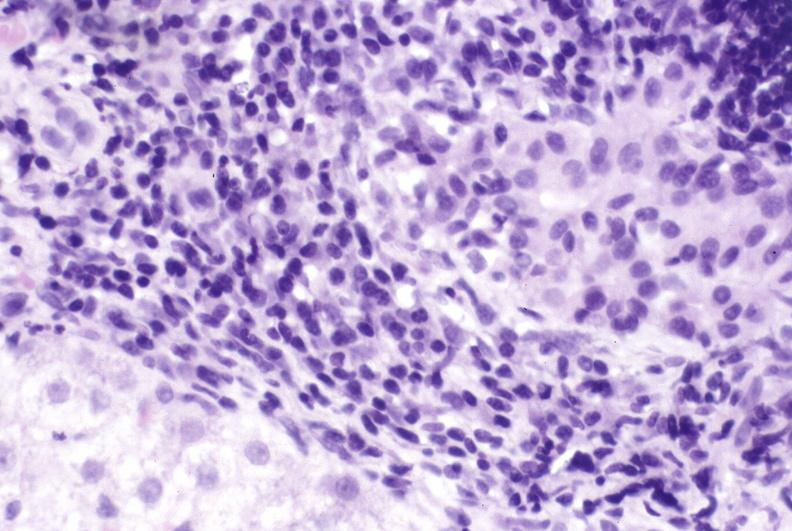what is present?
Answer the question using a single word or phrase. Liver 